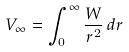Convert formula to latex. <formula><loc_0><loc_0><loc_500><loc_500>V _ { \infty } = \int _ { 0 } ^ { \infty } \frac { W } { r ^ { 2 } } \, d r</formula> 